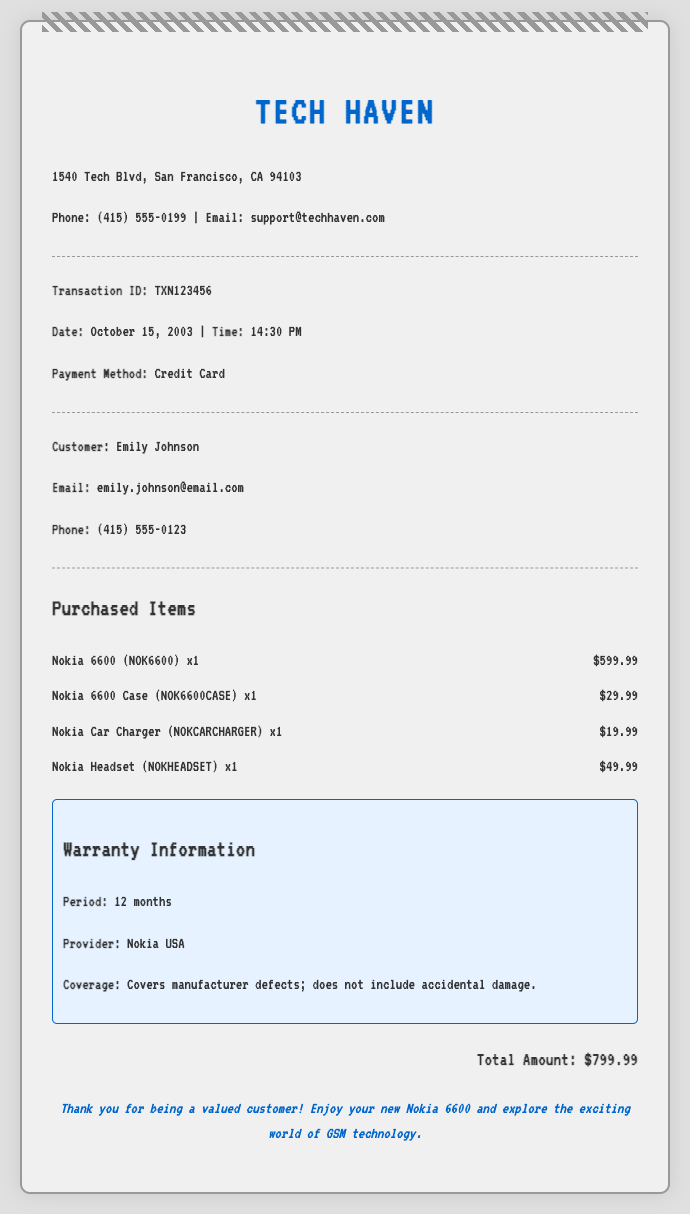what is the transaction ID? The transaction ID is listed for identifying the purchase, which is TXN123456.
Answer: TXN123456 what was the total amount spent? The total amount is displayed at the bottom of the receipt, which sums the cost of the items purchased.
Answer: $799.99 who is the customer? The customer’s name is specified in the document, which is Emily Johnson.
Answer: Emily Johnson what accessories were purchased with the phone? Several items are listed under purchased items, including a case, car charger, and headset.
Answer: Case, Car Charger, Headset when was the transaction made? The date is recorded in the transaction details section, which indicates the exact day of the purchase.
Answer: October 15, 2003 what is the warranty coverage? Warranty details describe what is covered in the warranty period, specifically mentioning manufacturer defects.
Answer: Covers manufacturer defects what is the name of the store? The name of the establishment where the purchase was made is prominently displayed at the top of the receipt.
Answer: Tech Haven what payment method was used? The method of payment can be found in the transaction details section, indicating how the payment was made.
Answer: Credit Card how long is the warranty period for the phone? The warranty period is detailed in the warranty information, showing how long the warranty lasts.
Answer: 12 months 